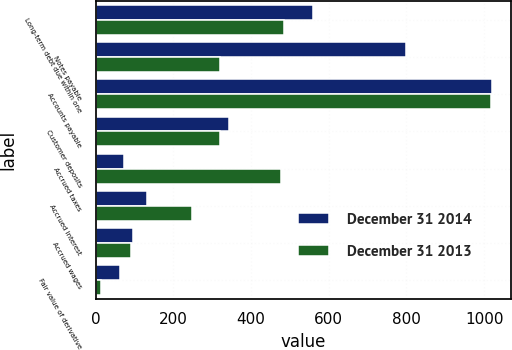Convert chart. <chart><loc_0><loc_0><loc_500><loc_500><stacked_bar_chart><ecel><fcel>Long-term debt due within one<fcel>Notes payable<fcel>Accounts payable<fcel>Customer deposits<fcel>Accrued taxes<fcel>Accrued interest<fcel>Accrued wages<fcel>Fair value of derivative<nl><fcel>December 31 2014<fcel>560<fcel>800<fcel>1019<fcel>344<fcel>72<fcel>132<fcel>95<fcel>64<nl><fcel>December 31 2013<fcel>485<fcel>321<fcel>1017<fcel>321<fcel>476<fcel>249<fcel>92<fcel>13<nl></chart> 